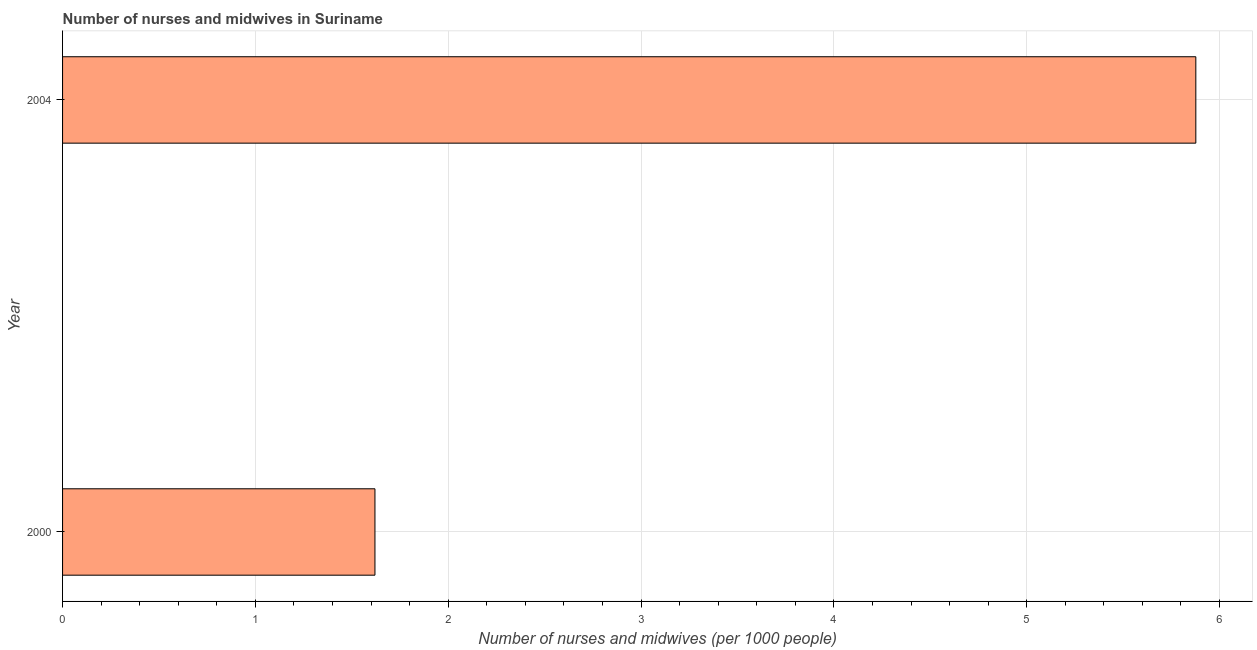What is the title of the graph?
Offer a terse response. Number of nurses and midwives in Suriname. What is the label or title of the X-axis?
Offer a terse response. Number of nurses and midwives (per 1000 people). What is the label or title of the Y-axis?
Your answer should be compact. Year. What is the number of nurses and midwives in 2000?
Offer a very short reply. 1.62. Across all years, what is the maximum number of nurses and midwives?
Offer a very short reply. 5.88. Across all years, what is the minimum number of nurses and midwives?
Provide a short and direct response. 1.62. In which year was the number of nurses and midwives minimum?
Keep it short and to the point. 2000. What is the sum of the number of nurses and midwives?
Your answer should be very brief. 7.5. What is the difference between the number of nurses and midwives in 2000 and 2004?
Keep it short and to the point. -4.26. What is the average number of nurses and midwives per year?
Make the answer very short. 3.75. What is the median number of nurses and midwives?
Provide a succinct answer. 3.75. In how many years, is the number of nurses and midwives greater than 2.4 ?
Ensure brevity in your answer.  1. Do a majority of the years between 2000 and 2004 (inclusive) have number of nurses and midwives greater than 1.4 ?
Give a very brief answer. Yes. What is the ratio of the number of nurses and midwives in 2000 to that in 2004?
Keep it short and to the point. 0.28. Is the number of nurses and midwives in 2000 less than that in 2004?
Your answer should be very brief. Yes. In how many years, is the number of nurses and midwives greater than the average number of nurses and midwives taken over all years?
Ensure brevity in your answer.  1. How many bars are there?
Ensure brevity in your answer.  2. Are all the bars in the graph horizontal?
Your answer should be very brief. Yes. Are the values on the major ticks of X-axis written in scientific E-notation?
Give a very brief answer. No. What is the Number of nurses and midwives (per 1000 people) of 2000?
Your response must be concise. 1.62. What is the Number of nurses and midwives (per 1000 people) in 2004?
Ensure brevity in your answer.  5.88. What is the difference between the Number of nurses and midwives (per 1000 people) in 2000 and 2004?
Your answer should be very brief. -4.26. What is the ratio of the Number of nurses and midwives (per 1000 people) in 2000 to that in 2004?
Ensure brevity in your answer.  0.28. 